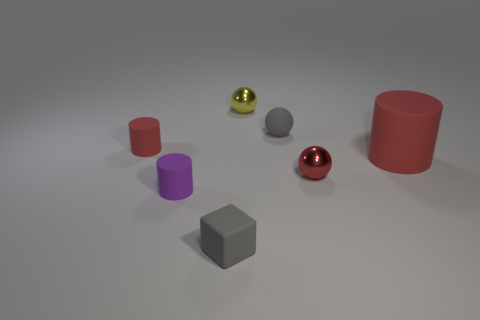Is the red cylinder that is right of the small gray block made of the same material as the purple cylinder?
Provide a succinct answer. Yes. Is the number of red matte objects in front of the large rubber thing the same as the number of small purple matte objects right of the tiny red shiny sphere?
Your response must be concise. Yes. Is there any other thing that is the same size as the rubber ball?
Make the answer very short. Yes. What is the material of the tiny gray thing that is the same shape as the small red metallic object?
Give a very brief answer. Rubber. Is there a red object that is behind the tiny object that is behind the small gray rubber thing on the right side of the tiny rubber block?
Make the answer very short. No. There is a small red thing that is behind the big red cylinder; is its shape the same as the small metal thing to the right of the yellow thing?
Your response must be concise. No. Is the number of yellow objects to the left of the tiny yellow metallic thing greater than the number of tiny cylinders?
Your response must be concise. No. How many things are purple matte cylinders or big cyan shiny cylinders?
Make the answer very short. 1. What color is the big cylinder?
Provide a short and direct response. Red. How many other objects are there of the same color as the big matte thing?
Make the answer very short. 2. 